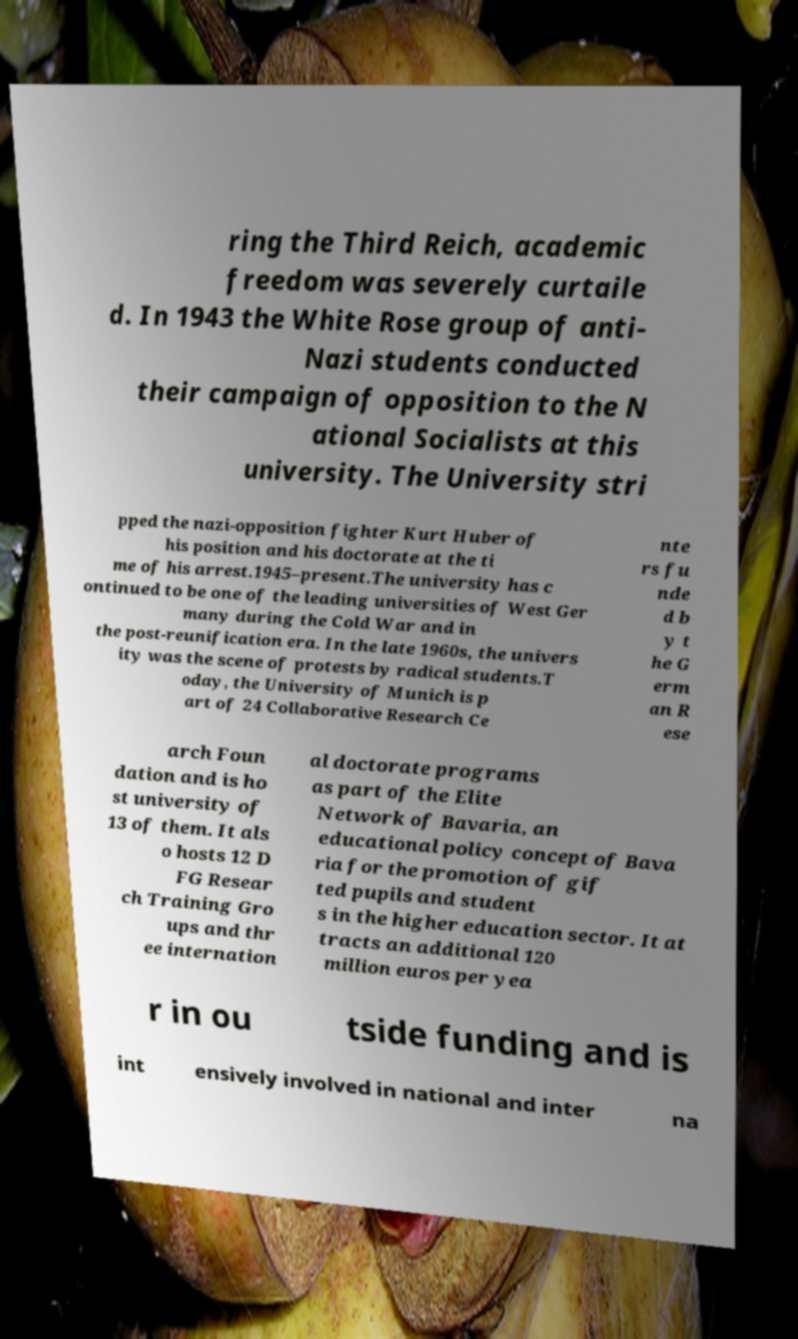Please read and relay the text visible in this image. What does it say? ring the Third Reich, academic freedom was severely curtaile d. In 1943 the White Rose group of anti- Nazi students conducted their campaign of opposition to the N ational Socialists at this university. The University stri pped the nazi-opposition fighter Kurt Huber of his position and his doctorate at the ti me of his arrest.1945–present.The university has c ontinued to be one of the leading universities of West Ger many during the Cold War and in the post-reunification era. In the late 1960s, the univers ity was the scene of protests by radical students.T oday, the University of Munich is p art of 24 Collaborative Research Ce nte rs fu nde d b y t he G erm an R ese arch Foun dation and is ho st university of 13 of them. It als o hosts 12 D FG Resear ch Training Gro ups and thr ee internation al doctorate programs as part of the Elite Network of Bavaria, an educational policy concept of Bava ria for the promotion of gif ted pupils and student s in the higher education sector. It at tracts an additional 120 million euros per yea r in ou tside funding and is int ensively involved in national and inter na 